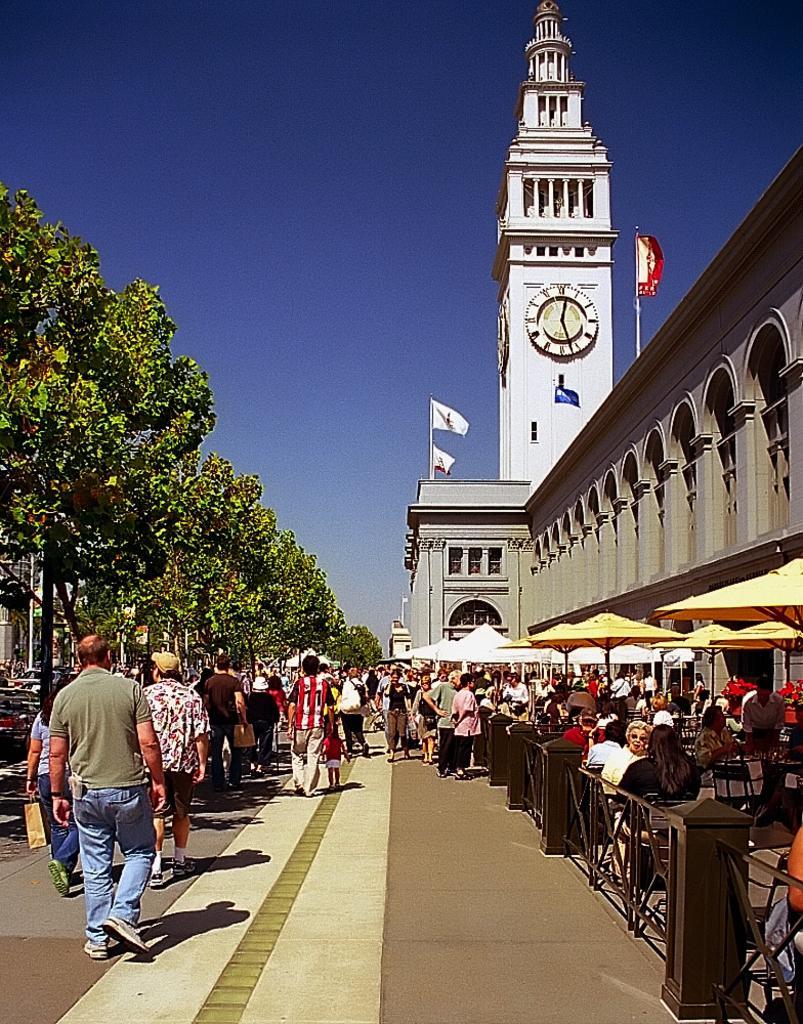How would you summarize this image in a sentence or two? In this image in the center. There are persons standing, walking and sitting. On the right side there is a building and there are tents which are white and yellow in colour and there is a clock tower, there are flags. On the left side there are trees. 